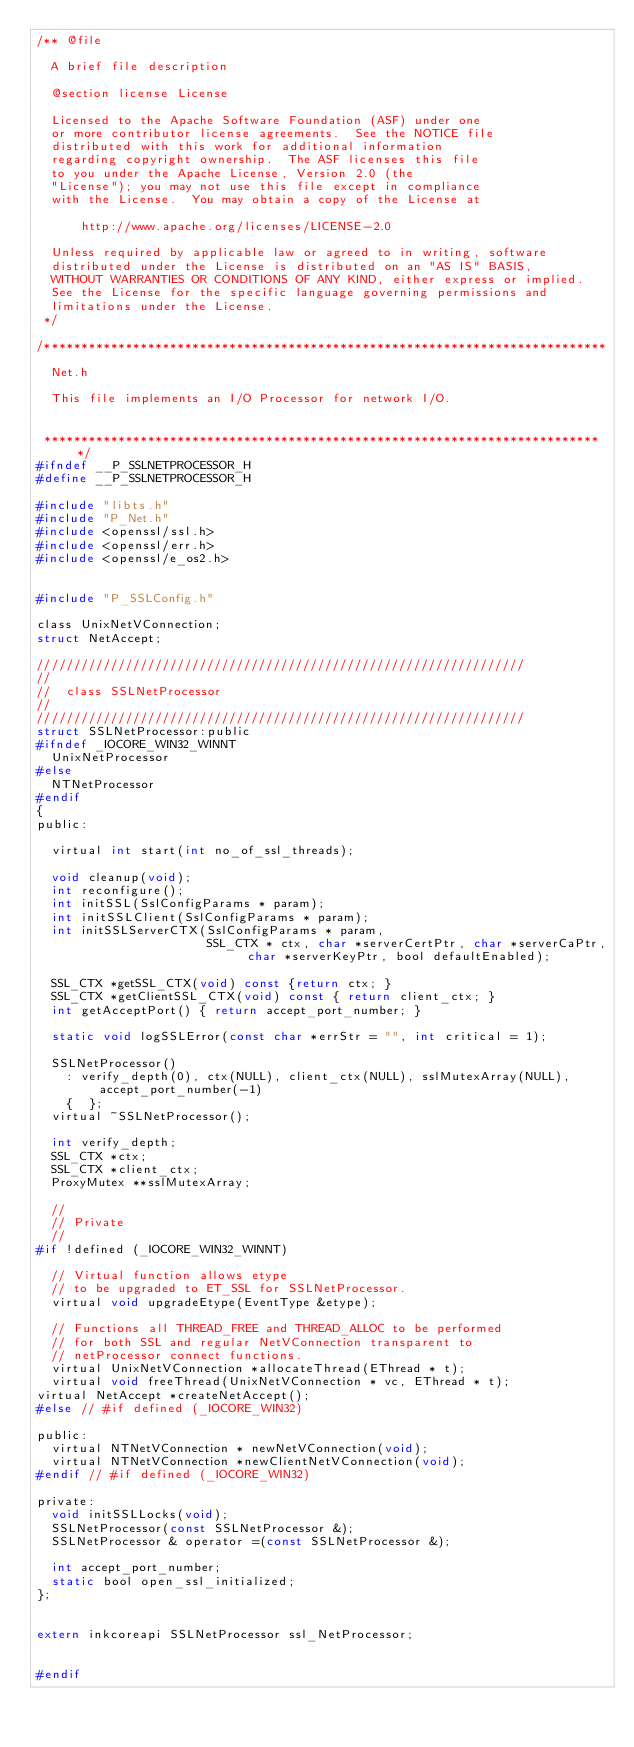Convert code to text. <code><loc_0><loc_0><loc_500><loc_500><_C_>/** @file

  A brief file description

  @section license License

  Licensed to the Apache Software Foundation (ASF) under one
  or more contributor license agreements.  See the NOTICE file
  distributed with this work for additional information
  regarding copyright ownership.  The ASF licenses this file
  to you under the Apache License, Version 2.0 (the
  "License"); you may not use this file except in compliance
  with the License.  You may obtain a copy of the License at

      http://www.apache.org/licenses/LICENSE-2.0

  Unless required by applicable law or agreed to in writing, software
  distributed under the License is distributed on an "AS IS" BASIS,
  WITHOUT WARRANTIES OR CONDITIONS OF ANY KIND, either express or implied.
  See the License for the specific language governing permissions and
  limitations under the License.
 */

/****************************************************************************

  Net.h

  This file implements an I/O Processor for network I/O.


 ****************************************************************************/
#ifndef __P_SSLNETPROCESSOR_H
#define __P_SSLNETPROCESSOR_H

#include "libts.h"
#include "P_Net.h"
#include <openssl/ssl.h>
#include <openssl/err.h>
#include <openssl/e_os2.h>


#include "P_SSLConfig.h"

class UnixNetVConnection;
struct NetAccept;

//////////////////////////////////////////////////////////////////
//
//  class SSLNetProcessor
//
//////////////////////////////////////////////////////////////////
struct SSLNetProcessor:public
#ifndef _IOCORE_WIN32_WINNT
  UnixNetProcessor
#else
  NTNetProcessor
#endif
{
public:

  virtual int start(int no_of_ssl_threads);

  void cleanup(void);
  int reconfigure();
  int initSSL(SslConfigParams * param);
  int initSSLClient(SslConfigParams * param);
  int initSSLServerCTX(SslConfigParams * param,
                       SSL_CTX * ctx, char *serverCertPtr, char *serverCaPtr, char *serverKeyPtr, bool defaultEnabled);

  SSL_CTX *getSSL_CTX(void) const {return ctx; }
  SSL_CTX *getClientSSL_CTX(void) const { return client_ctx; }
  int getAcceptPort() { return accept_port_number; }

  static void logSSLError(const char *errStr = "", int critical = 1);

  SSLNetProcessor()
    : verify_depth(0), ctx(NULL), client_ctx(NULL), sslMutexArray(NULL), accept_port_number(-1)
    {  };
  virtual ~SSLNetProcessor();

  int verify_depth;
  SSL_CTX *ctx;
  SSL_CTX *client_ctx;
  ProxyMutex **sslMutexArray;

  //
  // Private
  //
#if !defined (_IOCORE_WIN32_WINNT)

  // Virtual function allows etype
  // to be upgraded to ET_SSL for SSLNetProcessor.
  virtual void upgradeEtype(EventType &etype);

  // Functions all THREAD_FREE and THREAD_ALLOC to be performed
  // for both SSL and regular NetVConnection transparent to
  // netProcessor connect functions.
  virtual UnixNetVConnection *allocateThread(EThread * t);
  virtual void freeThread(UnixNetVConnection * vc, EThread * t);
virtual NetAccept *createNetAccept();
#else // #if defined (_IOCORE_WIN32)

public:
  virtual NTNetVConnection * newNetVConnection(void);
  virtual NTNetVConnection *newClientNetVConnection(void);
#endif // #if defined (_IOCORE_WIN32)

private:
  void initSSLLocks(void);
  SSLNetProcessor(const SSLNetProcessor &);
  SSLNetProcessor & operator =(const SSLNetProcessor &);

  int accept_port_number;
  static bool open_ssl_initialized;
};


extern inkcoreapi SSLNetProcessor ssl_NetProcessor;


#endif
</code> 